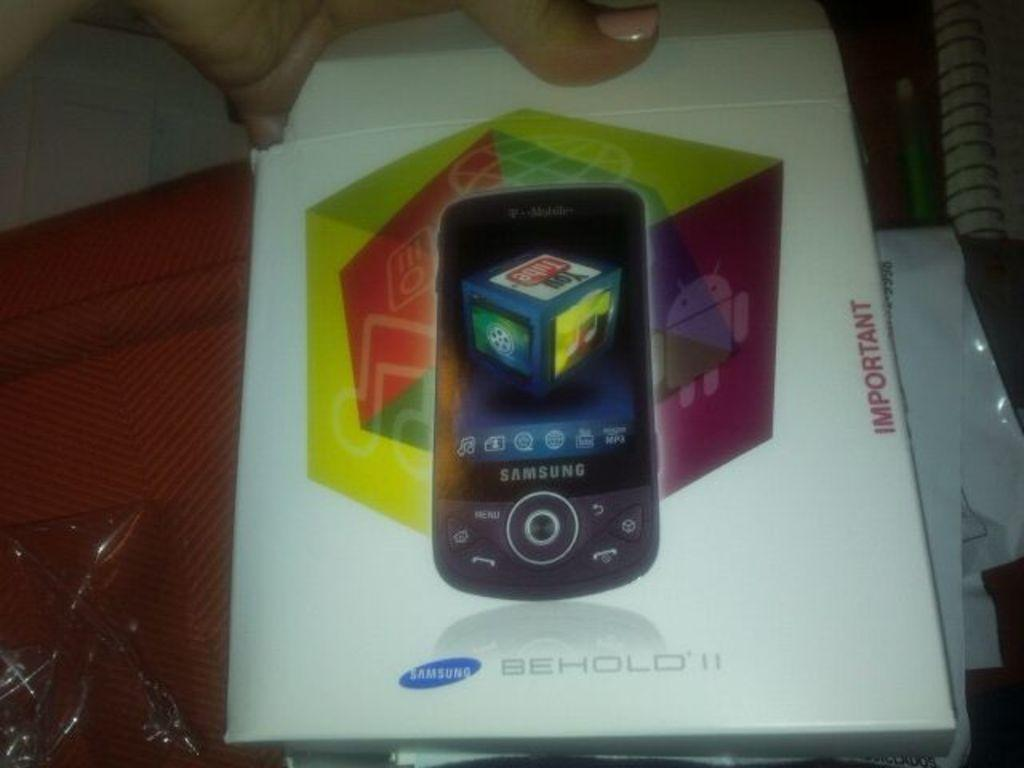<image>
Present a compact description of the photo's key features. a box with the word important on it 